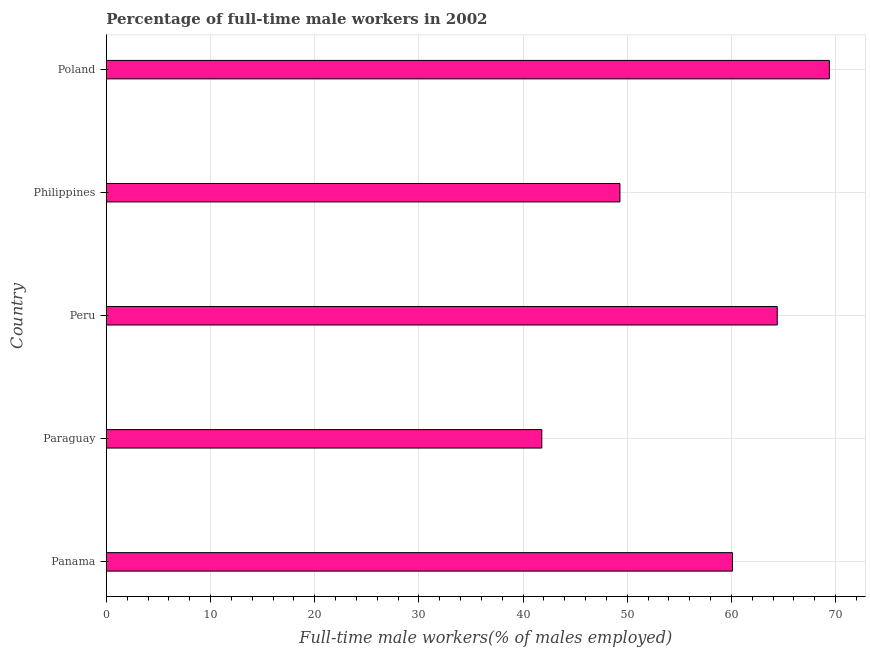Does the graph contain any zero values?
Your answer should be compact. No. What is the title of the graph?
Offer a terse response. Percentage of full-time male workers in 2002. What is the label or title of the X-axis?
Provide a succinct answer. Full-time male workers(% of males employed). What is the label or title of the Y-axis?
Keep it short and to the point. Country. What is the percentage of full-time male workers in Panama?
Your response must be concise. 60.1. Across all countries, what is the maximum percentage of full-time male workers?
Ensure brevity in your answer.  69.4. Across all countries, what is the minimum percentage of full-time male workers?
Provide a succinct answer. 41.8. In which country was the percentage of full-time male workers minimum?
Provide a short and direct response. Paraguay. What is the sum of the percentage of full-time male workers?
Provide a succinct answer. 285. What is the difference between the percentage of full-time male workers in Philippines and Poland?
Provide a short and direct response. -20.1. What is the median percentage of full-time male workers?
Offer a terse response. 60.1. What is the ratio of the percentage of full-time male workers in Paraguay to that in Philippines?
Make the answer very short. 0.85. Is the percentage of full-time male workers in Panama less than that in Philippines?
Keep it short and to the point. No. Is the sum of the percentage of full-time male workers in Panama and Peru greater than the maximum percentage of full-time male workers across all countries?
Your answer should be very brief. Yes. What is the difference between the highest and the lowest percentage of full-time male workers?
Make the answer very short. 27.6. How many bars are there?
Your answer should be compact. 5. Are all the bars in the graph horizontal?
Offer a terse response. Yes. How many countries are there in the graph?
Give a very brief answer. 5. What is the difference between two consecutive major ticks on the X-axis?
Your answer should be compact. 10. Are the values on the major ticks of X-axis written in scientific E-notation?
Offer a very short reply. No. What is the Full-time male workers(% of males employed) in Panama?
Your response must be concise. 60.1. What is the Full-time male workers(% of males employed) of Paraguay?
Your answer should be compact. 41.8. What is the Full-time male workers(% of males employed) of Peru?
Provide a short and direct response. 64.4. What is the Full-time male workers(% of males employed) in Philippines?
Offer a terse response. 49.3. What is the Full-time male workers(% of males employed) in Poland?
Your response must be concise. 69.4. What is the difference between the Full-time male workers(% of males employed) in Panama and Paraguay?
Offer a very short reply. 18.3. What is the difference between the Full-time male workers(% of males employed) in Panama and Peru?
Provide a succinct answer. -4.3. What is the difference between the Full-time male workers(% of males employed) in Paraguay and Peru?
Make the answer very short. -22.6. What is the difference between the Full-time male workers(% of males employed) in Paraguay and Poland?
Your answer should be compact. -27.6. What is the difference between the Full-time male workers(% of males employed) in Philippines and Poland?
Ensure brevity in your answer.  -20.1. What is the ratio of the Full-time male workers(% of males employed) in Panama to that in Paraguay?
Make the answer very short. 1.44. What is the ratio of the Full-time male workers(% of males employed) in Panama to that in Peru?
Your answer should be compact. 0.93. What is the ratio of the Full-time male workers(% of males employed) in Panama to that in Philippines?
Make the answer very short. 1.22. What is the ratio of the Full-time male workers(% of males employed) in Panama to that in Poland?
Make the answer very short. 0.87. What is the ratio of the Full-time male workers(% of males employed) in Paraguay to that in Peru?
Offer a very short reply. 0.65. What is the ratio of the Full-time male workers(% of males employed) in Paraguay to that in Philippines?
Offer a terse response. 0.85. What is the ratio of the Full-time male workers(% of males employed) in Paraguay to that in Poland?
Offer a very short reply. 0.6. What is the ratio of the Full-time male workers(% of males employed) in Peru to that in Philippines?
Your answer should be very brief. 1.31. What is the ratio of the Full-time male workers(% of males employed) in Peru to that in Poland?
Make the answer very short. 0.93. What is the ratio of the Full-time male workers(% of males employed) in Philippines to that in Poland?
Give a very brief answer. 0.71. 